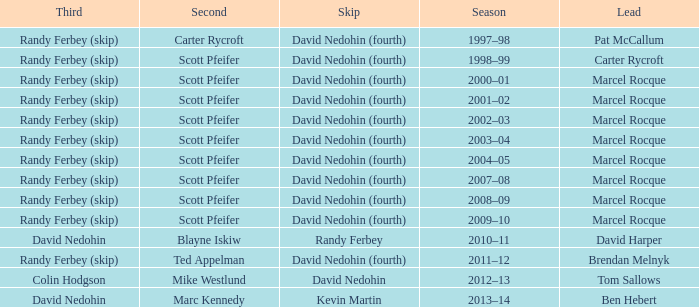Which Third has a Second of scott pfeifer? Randy Ferbey (skip), Randy Ferbey (skip), Randy Ferbey (skip), Randy Ferbey (skip), Randy Ferbey (skip), Randy Ferbey (skip), Randy Ferbey (skip), Randy Ferbey (skip), Randy Ferbey (skip). 